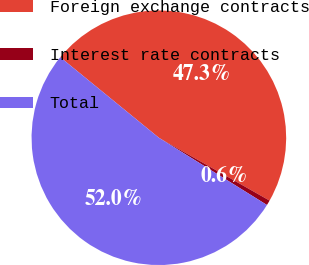Convert chart. <chart><loc_0><loc_0><loc_500><loc_500><pie_chart><fcel>Foreign exchange contracts<fcel>Interest rate contracts<fcel>Total<nl><fcel>47.32%<fcel>0.64%<fcel>52.05%<nl></chart> 